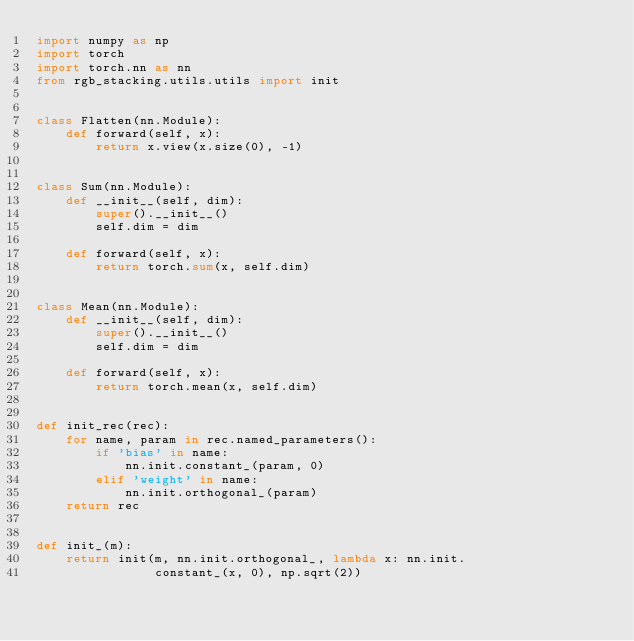<code> <loc_0><loc_0><loc_500><loc_500><_Python_>import numpy as np
import torch
import torch.nn as nn
from rgb_stacking.utils.utils import init


class Flatten(nn.Module):
    def forward(self, x):
        return x.view(x.size(0), -1)


class Sum(nn.Module):
    def __init__(self, dim):
        super().__init__()
        self.dim = dim

    def forward(self, x):
        return torch.sum(x, self.dim)


class Mean(nn.Module):
    def __init__(self, dim):
        super().__init__()
        self.dim = dim

    def forward(self, x):
        return torch.mean(x, self.dim)


def init_rec(rec):
    for name, param in rec.named_parameters():
        if 'bias' in name:
            nn.init.constant_(param, 0)
        elif 'weight' in name:
            nn.init.orthogonal_(param)
    return rec


def init_(m):
    return init(m, nn.init.orthogonal_, lambda x: nn.init.
                constant_(x, 0), np.sqrt(2))


</code> 